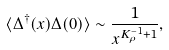<formula> <loc_0><loc_0><loc_500><loc_500>\langle \Delta ^ { \dag } ( x ) \Delta ( 0 ) \rangle \sim \frac { 1 } { x ^ { K _ { \rho } ^ { - 1 } + 1 } } ,</formula> 